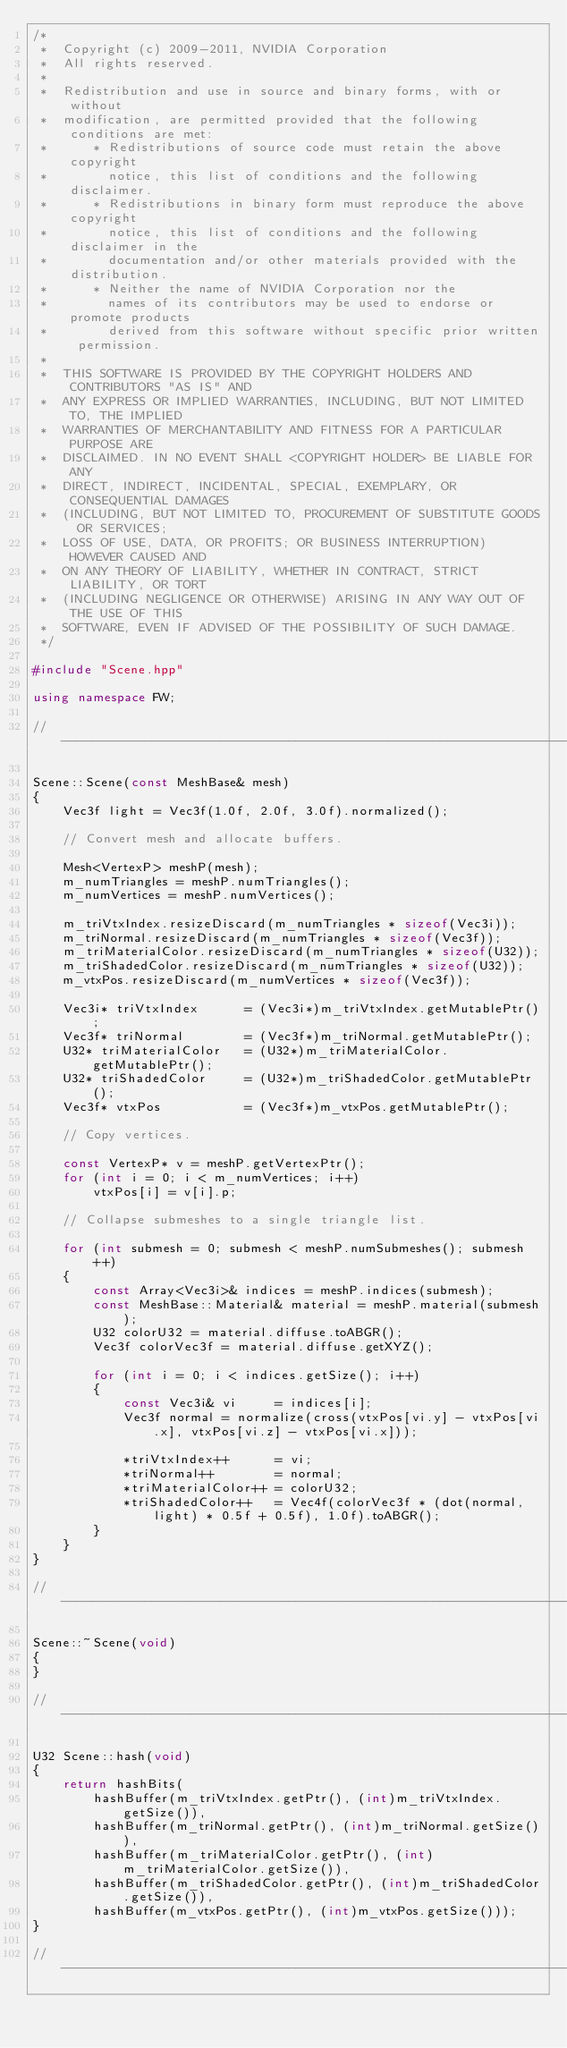Convert code to text. <code><loc_0><loc_0><loc_500><loc_500><_C++_>/*
 *  Copyright (c) 2009-2011, NVIDIA Corporation
 *  All rights reserved.
 *
 *  Redistribution and use in source and binary forms, with or without
 *  modification, are permitted provided that the following conditions are met:
 *      * Redistributions of source code must retain the above copyright
 *        notice, this list of conditions and the following disclaimer.
 *      * Redistributions in binary form must reproduce the above copyright
 *        notice, this list of conditions and the following disclaimer in the
 *        documentation and/or other materials provided with the distribution.
 *      * Neither the name of NVIDIA Corporation nor the
 *        names of its contributors may be used to endorse or promote products
 *        derived from this software without specific prior written permission.
 *
 *  THIS SOFTWARE IS PROVIDED BY THE COPYRIGHT HOLDERS AND CONTRIBUTORS "AS IS" AND
 *  ANY EXPRESS OR IMPLIED WARRANTIES, INCLUDING, BUT NOT LIMITED TO, THE IMPLIED
 *  WARRANTIES OF MERCHANTABILITY AND FITNESS FOR A PARTICULAR PURPOSE ARE
 *  DISCLAIMED. IN NO EVENT SHALL <COPYRIGHT HOLDER> BE LIABLE FOR ANY
 *  DIRECT, INDIRECT, INCIDENTAL, SPECIAL, EXEMPLARY, OR CONSEQUENTIAL DAMAGES
 *  (INCLUDING, BUT NOT LIMITED TO, PROCUREMENT OF SUBSTITUTE GOODS OR SERVICES;
 *  LOSS OF USE, DATA, OR PROFITS; OR BUSINESS INTERRUPTION) HOWEVER CAUSED AND
 *  ON ANY THEORY OF LIABILITY, WHETHER IN CONTRACT, STRICT LIABILITY, OR TORT
 *  (INCLUDING NEGLIGENCE OR OTHERWISE) ARISING IN ANY WAY OUT OF THE USE OF THIS
 *  SOFTWARE, EVEN IF ADVISED OF THE POSSIBILITY OF SUCH DAMAGE.
 */

#include "Scene.hpp"

using namespace FW;

//------------------------------------------------------------------------

Scene::Scene(const MeshBase& mesh)
{
    Vec3f light = Vec3f(1.0f, 2.0f, 3.0f).normalized();

    // Convert mesh and allocate buffers.

    Mesh<VertexP> meshP(mesh);
    m_numTriangles = meshP.numTriangles();
    m_numVertices = meshP.numVertices();

    m_triVtxIndex.resizeDiscard(m_numTriangles * sizeof(Vec3i));
    m_triNormal.resizeDiscard(m_numTriangles * sizeof(Vec3f));
    m_triMaterialColor.resizeDiscard(m_numTriangles * sizeof(U32));
    m_triShadedColor.resizeDiscard(m_numTriangles * sizeof(U32));
    m_vtxPos.resizeDiscard(m_numVertices * sizeof(Vec3f));

    Vec3i* triVtxIndex      = (Vec3i*)m_triVtxIndex.getMutablePtr();
    Vec3f* triNormal        = (Vec3f*)m_triNormal.getMutablePtr();
    U32* triMaterialColor   = (U32*)m_triMaterialColor.getMutablePtr();
    U32* triShadedColor     = (U32*)m_triShadedColor.getMutablePtr();
    Vec3f* vtxPos           = (Vec3f*)m_vtxPos.getMutablePtr();

    // Copy vertices.

    const VertexP* v = meshP.getVertexPtr();
    for (int i = 0; i < m_numVertices; i++)
        vtxPos[i] = v[i].p;

    // Collapse submeshes to a single triangle list.

    for (int submesh = 0; submesh < meshP.numSubmeshes(); submesh++)
    {
        const Array<Vec3i>& indices = meshP.indices(submesh);
        const MeshBase::Material& material = meshP.material(submesh);
        U32 colorU32 = material.diffuse.toABGR();
        Vec3f colorVec3f = material.diffuse.getXYZ();

        for (int i = 0; i < indices.getSize(); i++)
        {
            const Vec3i& vi     = indices[i];
            Vec3f normal = normalize(cross(vtxPos[vi.y] - vtxPos[vi.x], vtxPos[vi.z] - vtxPos[vi.x]));

            *triVtxIndex++      = vi;
            *triNormal++        = normal;
            *triMaterialColor++ = colorU32;
            *triShadedColor++   = Vec4f(colorVec3f * (dot(normal, light) * 0.5f + 0.5f), 1.0f).toABGR();
        }
    }
}

//------------------------------------------------------------------------

Scene::~Scene(void)
{
}

//------------------------------------------------------------------------

U32 Scene::hash(void)
{
    return hashBits(
        hashBuffer(m_triVtxIndex.getPtr(), (int)m_triVtxIndex.getSize()),
        hashBuffer(m_triNormal.getPtr(), (int)m_triNormal.getSize()),
        hashBuffer(m_triMaterialColor.getPtr(), (int)m_triMaterialColor.getSize()),
        hashBuffer(m_triShadedColor.getPtr(), (int)m_triShadedColor.getSize()),
        hashBuffer(m_vtxPos.getPtr(), (int)m_vtxPos.getSize()));
}

//------------------------------------------------------------------------
</code> 